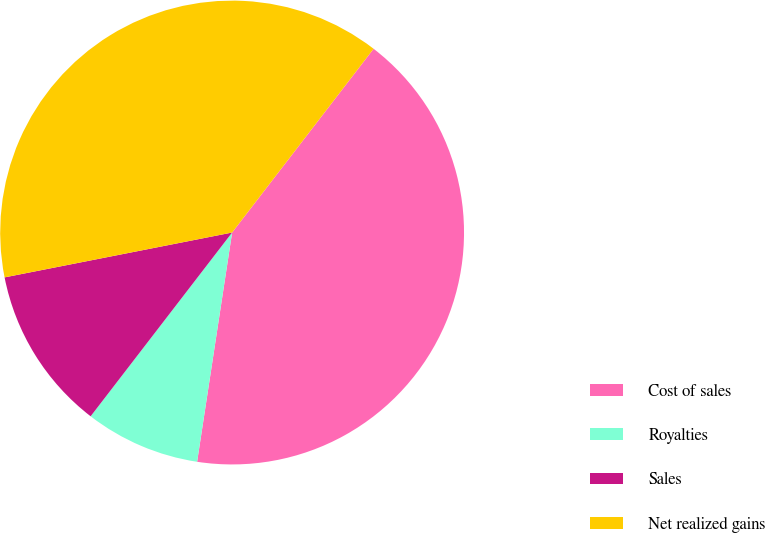Convert chart to OTSL. <chart><loc_0><loc_0><loc_500><loc_500><pie_chart><fcel>Cost of sales<fcel>Royalties<fcel>Sales<fcel>Net realized gains<nl><fcel>41.97%<fcel>8.03%<fcel>11.46%<fcel>38.54%<nl></chart> 